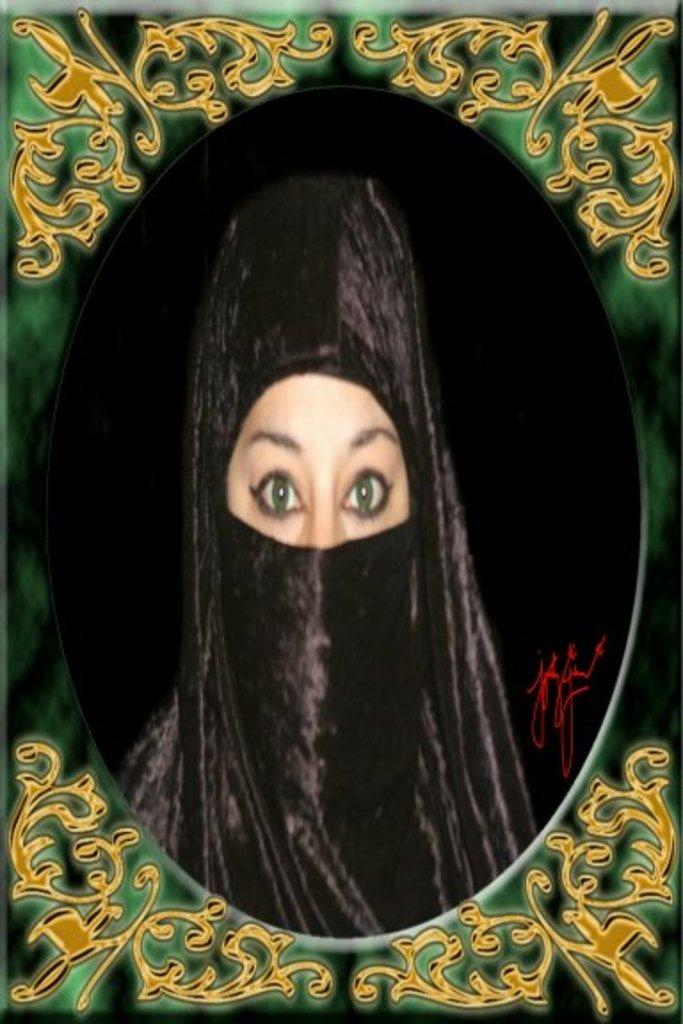What is the appearance of the person in the image? The person in the image is covered with a black color cloth. What is in front of the person in the image? There is a green and gold frame in front of the person. What color is the background of the image? The background of the image is black. What is the price of the car the person is driving in the image? There is no car or driving activity present in the image; the person is covered with a black color cloth and standing in front of a green and gold frame. 